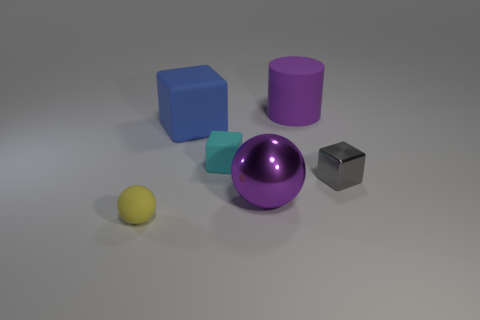Is the color of the large metal object the same as the big matte cylinder?
Your response must be concise. Yes. The large thing that is both to the right of the cyan object and behind the purple shiny thing has what shape?
Your response must be concise. Cylinder. There is a shiny block that is the same size as the cyan object; what is its color?
Your answer should be very brief. Gray. There is a purple shiny thing that is in front of the metal cube; is it the same size as the matte thing that is left of the large blue cube?
Offer a terse response. No. What is the size of the purple thing that is on the left side of the purple thing that is behind the tiny block on the left side of the gray object?
Your answer should be very brief. Large. What is the shape of the big purple thing that is behind the block that is left of the small cyan cube?
Your response must be concise. Cylinder. There is a big object in front of the small gray block; does it have the same color as the rubber cylinder?
Offer a terse response. Yes. What color is the cube that is in front of the large cube and left of the large purple cylinder?
Offer a terse response. Cyan. Are there any cyan things that have the same material as the yellow ball?
Provide a succinct answer. Yes. What is the size of the purple rubber cylinder?
Offer a terse response. Large. 